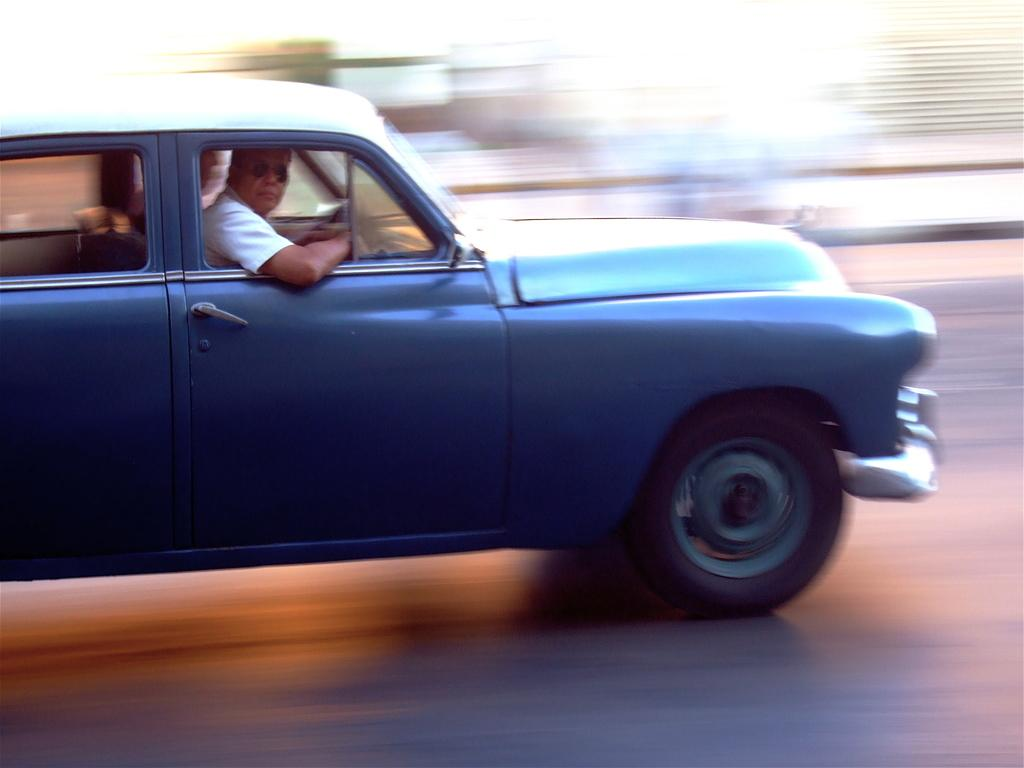What is the person wearing in the image? The person is wearing a white shirt in the image. What mode of transportation is the person using? The person is traveling in a blue car. Is there anyone else in the car with the person wearing a white shirt? Yes, there is another person sitting beside the person wearing a white shirt. What shape is the flesh of the person wearing a white shirt in the image? There is no mention of the shape of the person's flesh in the image, and it is not relevant to the description of the scene. 